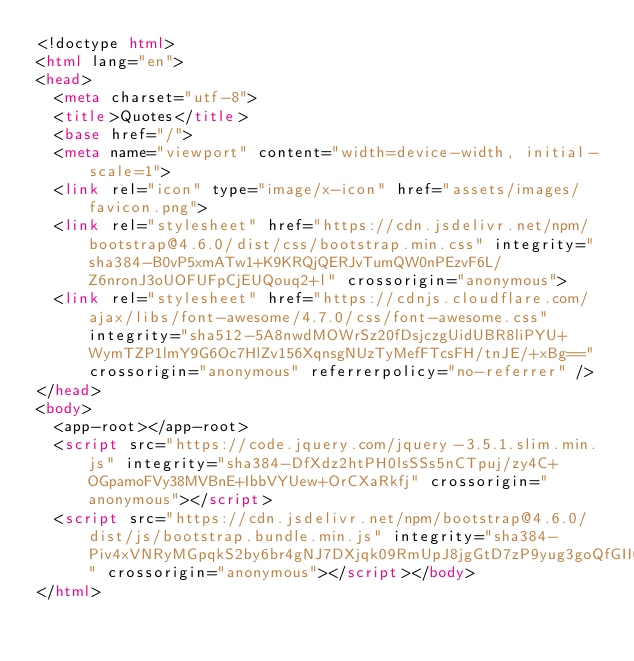<code> <loc_0><loc_0><loc_500><loc_500><_HTML_><!doctype html>
<html lang="en">
<head>
  <meta charset="utf-8">
  <title>Quotes</title>
  <base href="/">
  <meta name="viewport" content="width=device-width, initial-scale=1">
  <link rel="icon" type="image/x-icon" href="assets/images/favicon.png">
  <link rel="stylesheet" href="https://cdn.jsdelivr.net/npm/bootstrap@4.6.0/dist/css/bootstrap.min.css" integrity="sha384-B0vP5xmATw1+K9KRQjQERJvTumQW0nPEzvF6L/Z6nronJ3oUOFUFpCjEUQouq2+l" crossorigin="anonymous">
  <link rel="stylesheet" href="https://cdnjs.cloudflare.com/ajax/libs/font-awesome/4.7.0/css/font-awesome.css" integrity="sha512-5A8nwdMOWrSz20fDsjczgUidUBR8liPYU+WymTZP1lmY9G6Oc7HlZv156XqnsgNUzTyMefFTcsFH/tnJE/+xBg==" crossorigin="anonymous" referrerpolicy="no-referrer" />
</head>
<body>
  <app-root></app-root>
  <script src="https://code.jquery.com/jquery-3.5.1.slim.min.js" integrity="sha384-DfXdz2htPH0lsSSs5nCTpuj/zy4C+OGpamoFVy38MVBnE+IbbVYUew+OrCXaRkfj" crossorigin="anonymous"></script>
  <script src="https://cdn.jsdelivr.net/npm/bootstrap@4.6.0/dist/js/bootstrap.bundle.min.js" integrity="sha384-Piv4xVNRyMGpqkS2by6br4gNJ7DXjqk09RmUpJ8jgGtD7zP9yug3goQfGII0yAns" crossorigin="anonymous"></script></body>
</html>
</code> 